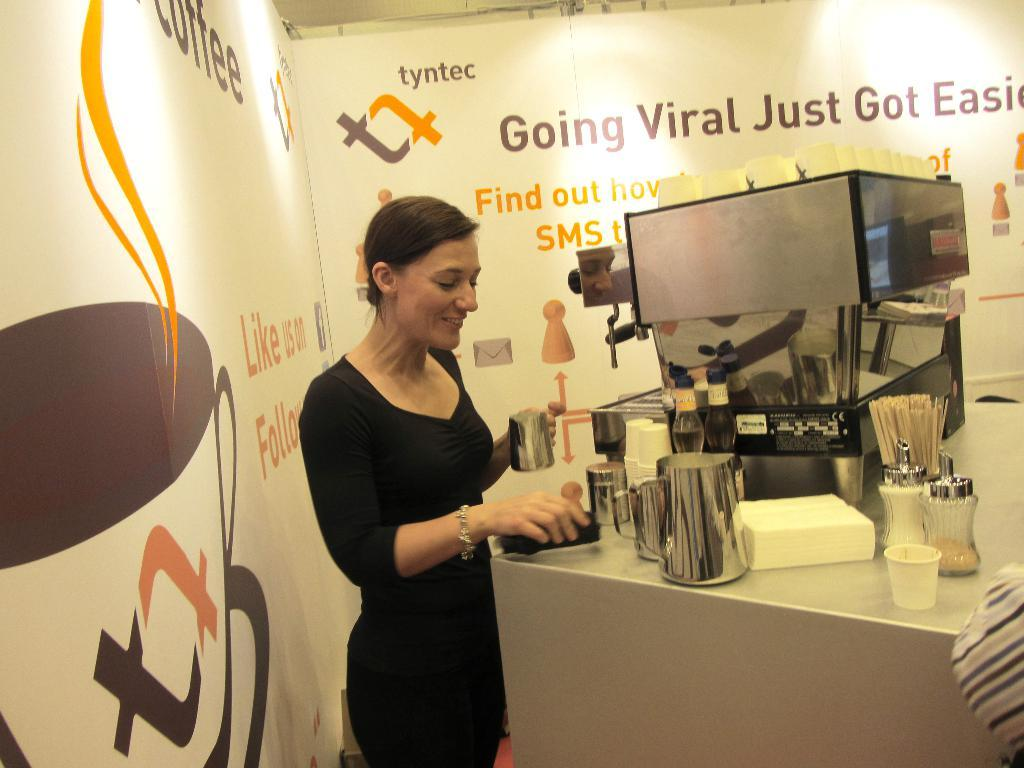Who or what is in the image? There is a person in the image. What is the person doing in the image? The person is standing in front of a table. What can be seen on the table? There are things placed on the table. What is written on the boards next to the table? There are boards with text on either side of the table. What type of apple is being used as a doorstop in the image? There is no apple or doorstop present in the image. Can you tell me how many toes the person has in the image? The image does not show the person's toes, so it is not possible to determine the number of toes they have. 